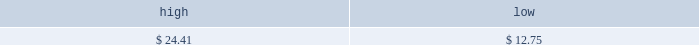Table of contents part ii price range our common stock commenced trading on the nasdaq national market under the symbol 201cmktx 201d on november 5 , 2004 .
Prior to that date , there was no public market for our common stock .
On november 4 , 2004 , the registration statement relating to our initial public offering was declared effective by the sec .
The high and low bid information for our common stock , as reported by nasdaq , was as follows : on march 28 , 2005 , the last reported closing price of our common stock on the nasdaq national market was $ 10.26 .
Holders there were approximately 188 holders of record of our common stock as of march 28 , 2005 .
Dividend policy we have not declared or paid any cash dividends on our capital stock since our inception .
We intend to retain future earnings to finance the operation and expansion of our business and do not anticipate paying any cash dividends in the foreseeable future .
In the event we decide to declare dividends on our common stock in the future , such declaration will be subject to the discretion of our board of directors .
Our board may take into account such matters as general business conditions , our financial results , capital requirements , contractual , legal , and regulatory restrictions on the payment of dividends by us to our stockholders or by our subsidiaries to us and any such other factors as our board may deem relevant .
Use of proceeds on november 4 , 2004 , the registration statement relating to our initial public offering ( no .
333-112718 ) was declared effective .
We received net proceeds from the sale of the shares of our common stock in the offering of $ 53.9 million , at an initial public offering price of $ 11.00 per share , after deducting underwriting discounts and commissions and estimated offering expenses .
Additionally , prior to the closing of the initial public offering , all outstanding shares of convertible preferred stock were converted into 14484493 shares of common stock and 4266310 shares of non-voting common stock .
The underwriters for our initial public offering were credit suisse first boston llc , j.p .
Morgan securities inc. , banc of america securities llc , bear , stearns & co .
Inc .
And ubs securities llc .
All of the underwriters are affiliates of some of our broker-dealer clients and affiliates of some our institutional investor clients .
In addition , affiliates of all the underwriters are stockholders of ours .
Except for salaries , and reimbursements for travel expenses and other out-of-pocket costs incurred in the ordinary course of business , none of the proceeds from the offering have been paid by us , directly or indirectly , to any of our directors or officers or any of their associates , or to any persons owning ten percent or more of our outstanding stock or to any of our affiliates .
As of december 31 , 2004 , we have not used any of the net proceeds from the initial public offering for product development costs , sales and marketing activities and working capital .
We have invested the proceeds from the offering in cash and cash equivalents and short-term marketable securities pending their use for these or other purposes .
Item 5 .
Market for registrant 2019s common equity , related stockholder matters and issuer purchases of equity securities november 5 , 2004 december 31 , 2004 .

What was the market cap of common stock as of march 28 , 2005? 
Computations: (10.26 * 188)
Answer: 1928.88. 